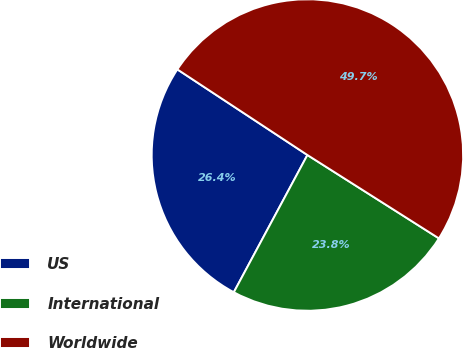<chart> <loc_0><loc_0><loc_500><loc_500><pie_chart><fcel>US<fcel>International<fcel>Worldwide<nl><fcel>26.43%<fcel>23.84%<fcel>49.72%<nl></chart> 